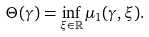Convert formula to latex. <formula><loc_0><loc_0><loc_500><loc_500>\Theta ( \gamma ) = \inf _ { \xi \in \mathbb { R } } \mu _ { 1 } ( \gamma , \xi ) .</formula> 